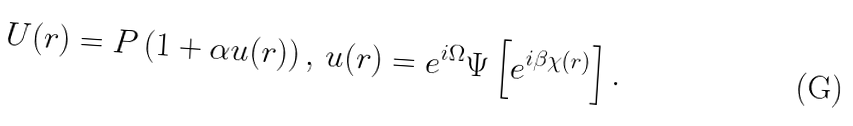<formula> <loc_0><loc_0><loc_500><loc_500>U ( { r } ) = P \left ( 1 + \alpha u ( { r } ) \right ) , \, u ( { r } ) = e ^ { i \Omega } \Psi \left [ e ^ { i \beta \chi ( { r } ) } \right ] .</formula> 